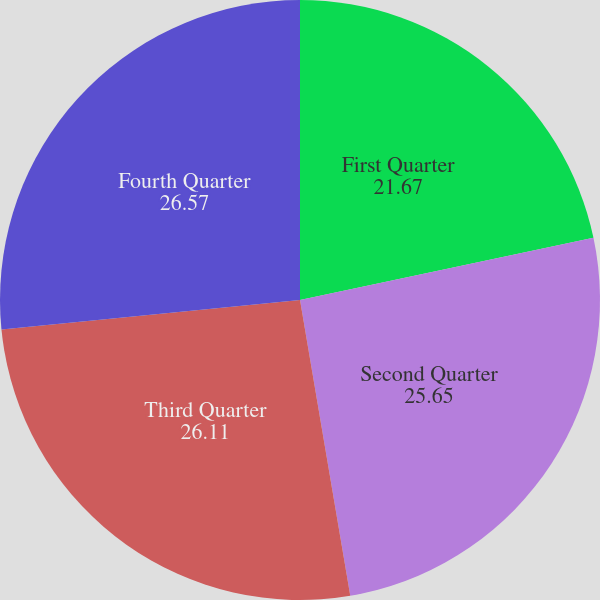Convert chart. <chart><loc_0><loc_0><loc_500><loc_500><pie_chart><fcel>First Quarter<fcel>Second Quarter<fcel>Third Quarter<fcel>Fourth Quarter<nl><fcel>21.67%<fcel>25.65%<fcel>26.11%<fcel>26.57%<nl></chart> 